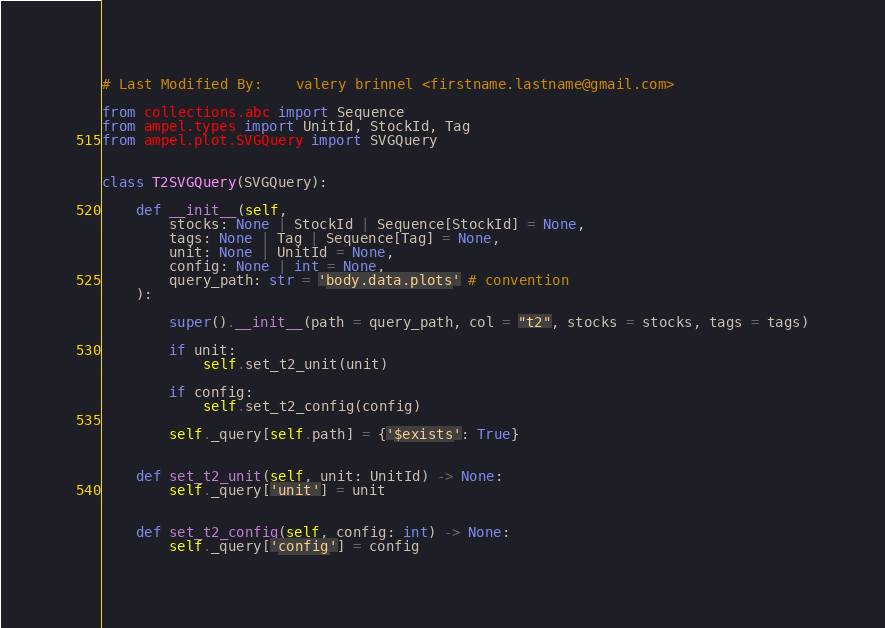<code> <loc_0><loc_0><loc_500><loc_500><_Python_># Last Modified By:    valery brinnel <firstname.lastname@gmail.com>

from collections.abc import Sequence
from ampel.types import UnitId, StockId, Tag
from ampel.plot.SVGQuery import SVGQuery


class T2SVGQuery(SVGQuery):

	def __init__(self,
		stocks: None | StockId | Sequence[StockId] = None,
		tags: None | Tag | Sequence[Tag] = None,
		unit: None | UnitId = None,
		config: None | int = None,
		query_path: str = 'body.data.plots' # convention
	):

		super().__init__(path = query_path, col = "t2", stocks = stocks, tags = tags)

		if unit:
			self.set_t2_unit(unit)

		if config:
			self.set_t2_config(config)

		self._query[self.path] = {'$exists': True}


	def set_t2_unit(self, unit: UnitId) -> None:
		self._query['unit'] = unit


	def set_t2_config(self, config: int) -> None:
		self._query['config'] = config
</code> 